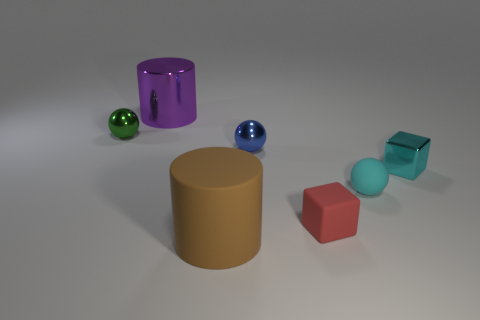Add 2 blue balls. How many objects exist? 9 Subtract all small blue balls. How many balls are left? 2 Subtract all blocks. How many objects are left? 5 Subtract all red cubes. How many cubes are left? 1 Add 3 tiny red rubber blocks. How many tiny red rubber blocks are left? 4 Add 2 red objects. How many red objects exist? 3 Subtract 0 green cylinders. How many objects are left? 7 Subtract all yellow cylinders. Subtract all purple cubes. How many cylinders are left? 2 Subtract all brown blocks. How many green balls are left? 1 Subtract all large gray matte cylinders. Subtract all large matte things. How many objects are left? 6 